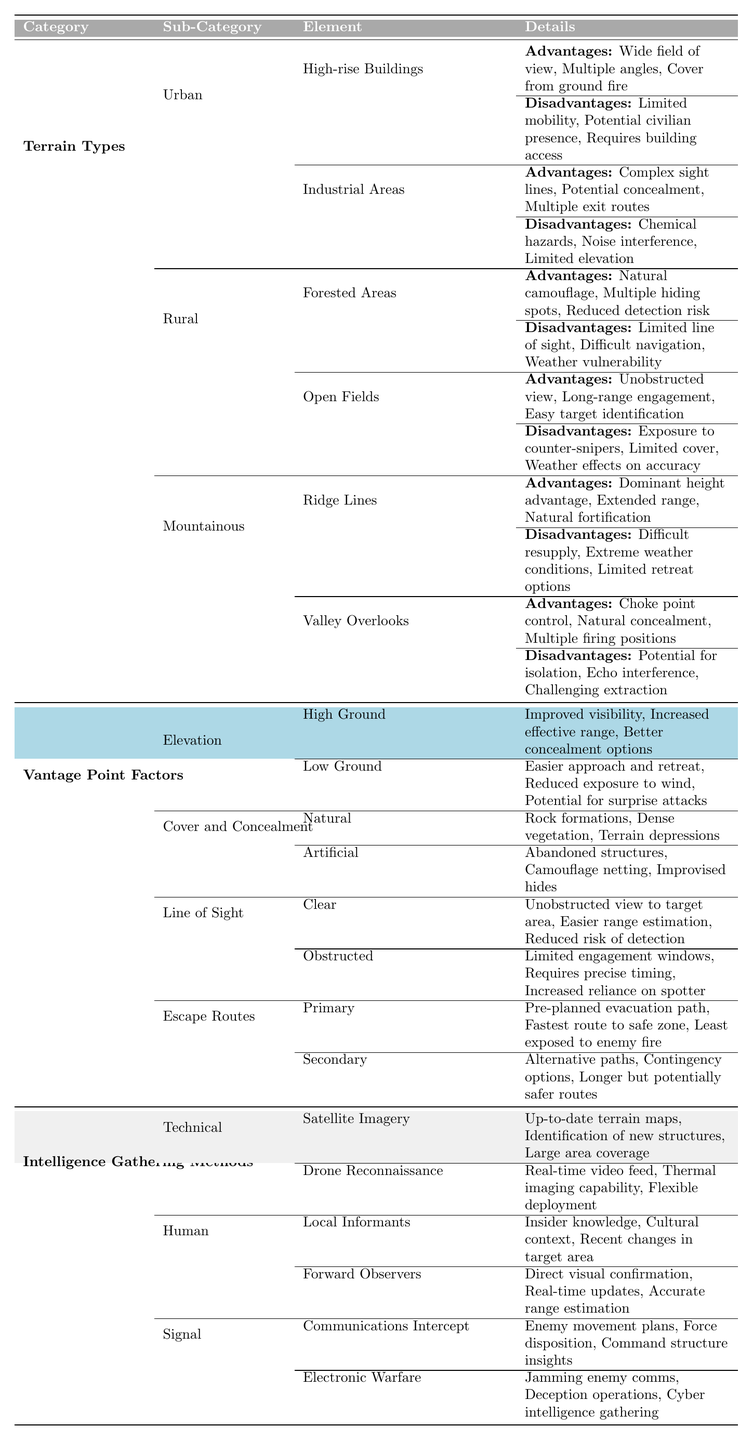What are the advantages of using high-rise buildings in urban terrain? The table lists the advantages of high-rise buildings under the Urban terrain type: they provide a wide field of view, allow for multiple angles of engagement, and offer cover from ground fire.
Answer: Wide field of view, multiple angles, cover from ground fire What disadvantages do industrial areas present in urban settings? The disadvantages listed for industrial areas include chemical hazards, noise interference, and limited elevation, which can impact operability and safety.
Answer: Chemical hazards, noise interference, limited elevation Which vantage point factor offers improved visibility? Under the section for elevation, it is stated that high ground provides improved visibility compared to low ground.
Answer: High ground What are the advantages of having a vantage point in an open field? The advantages listed for open fields are an unobstructed view, long-range engagement, and easy target identification, making them ideal for sniping.
Answer: Unobstructed view, long-range engagement, easy target identification Is it true that natural cover includes dense vegetation? The table confirms that dense vegetation is listed as one of the forms of natural cover, so the statement is true.
Answer: Yes What are the primary escape route advantages? The primary escape route advantages include having a pre-planned evacuation path, being the fastest route to a safe zone, and being least exposed to enemy fire, as noted in the table.
Answer: Pre-planned path, fastest route, least exposed to enemy fire Which terrain type has the greatest height advantage mentioned? The terrain type 'Mountainous' features ridge lines, which are noted for their dominant height advantage.
Answer: Mountainous (ridge lines) Can you summarize the main intelligence gathering methods? The methods include technical means like satellite imagery and drone reconnaissance, human means through local informants and forward observers, and signal methods such as communications intercept and electronic warfare.
Answer: Technical, Human, Signal What are the disadvantages of using valley overlooks? The disadvantages identified for valley overlooks are potential isolation, echo interference, and challenging extraction, indicating the risks of this vantage point.
Answer: Potential isolation, echo interference, challenging extraction Which type of terrain is noted for having complex sight lines? The data specifies that industrial areas within urban terrain have complex sight lines, making them advantageous for concealment and tactics.
Answer: Industrial areas (Urban) 